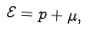Convert formula to latex. <formula><loc_0><loc_0><loc_500><loc_500>\mathcal { E } = p + \mu ,</formula> 